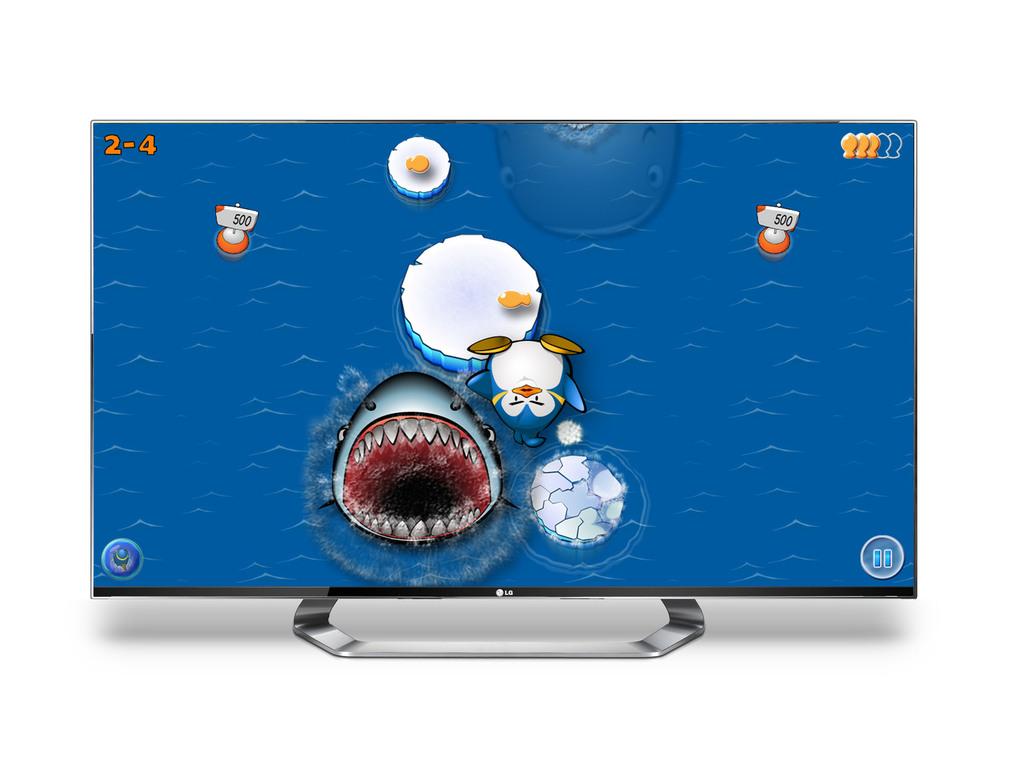How many points are the buoys?
Ensure brevity in your answer.  500. What type of machine is being used here?
Keep it short and to the point. Answering does not require reading text in the image. 